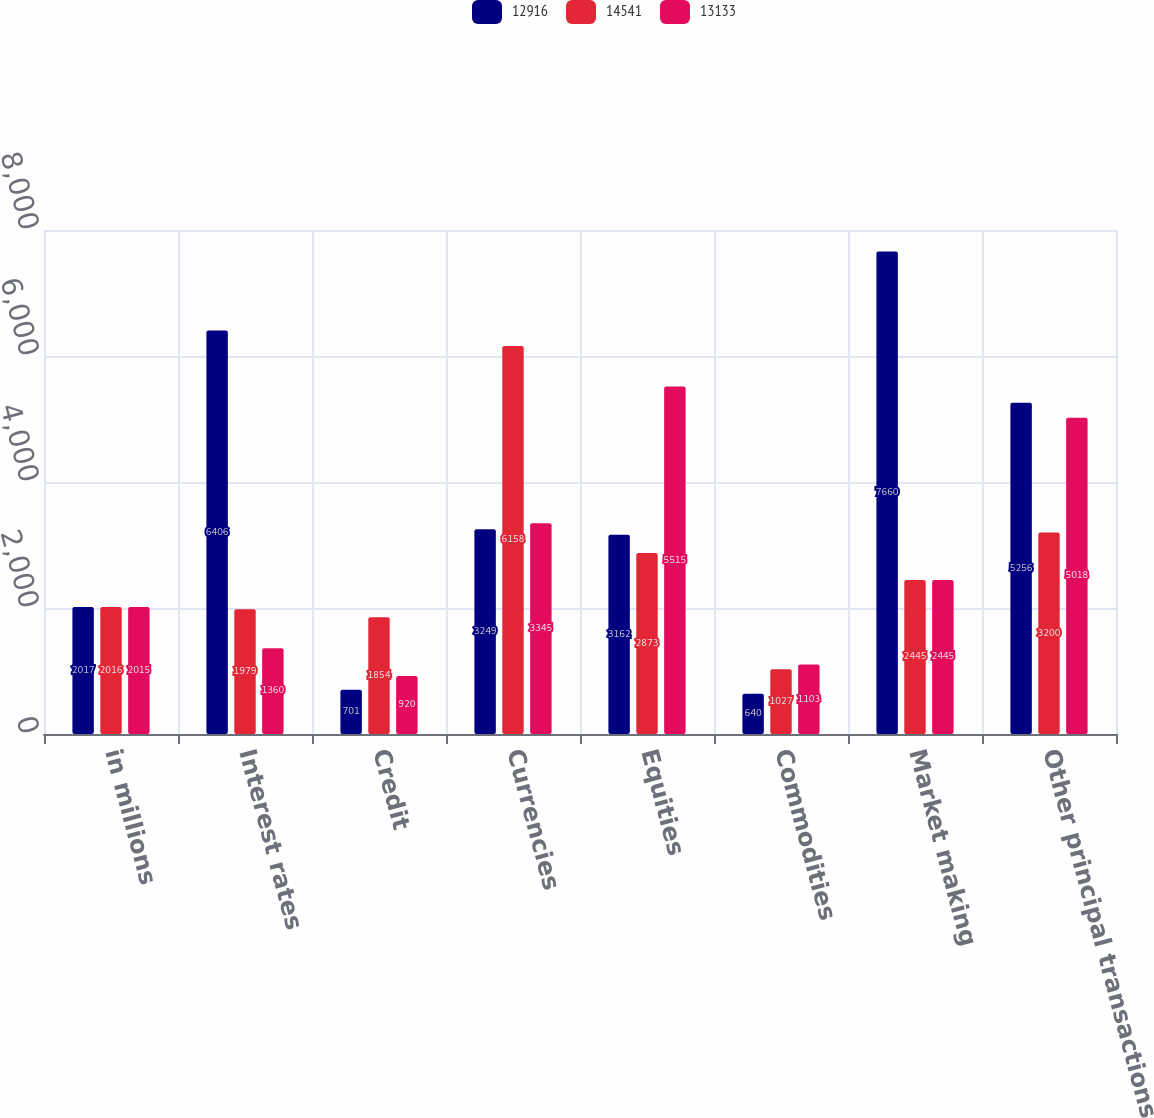<chart> <loc_0><loc_0><loc_500><loc_500><stacked_bar_chart><ecel><fcel>in millions<fcel>Interest rates<fcel>Credit<fcel>Currencies<fcel>Equities<fcel>Commodities<fcel>Market making<fcel>Other principal transactions<nl><fcel>12916<fcel>2017<fcel>6406<fcel>701<fcel>3249<fcel>3162<fcel>640<fcel>7660<fcel>5256<nl><fcel>14541<fcel>2016<fcel>1979<fcel>1854<fcel>6158<fcel>2873<fcel>1027<fcel>2445<fcel>3200<nl><fcel>13133<fcel>2015<fcel>1360<fcel>920<fcel>3345<fcel>5515<fcel>1103<fcel>2445<fcel>5018<nl></chart> 